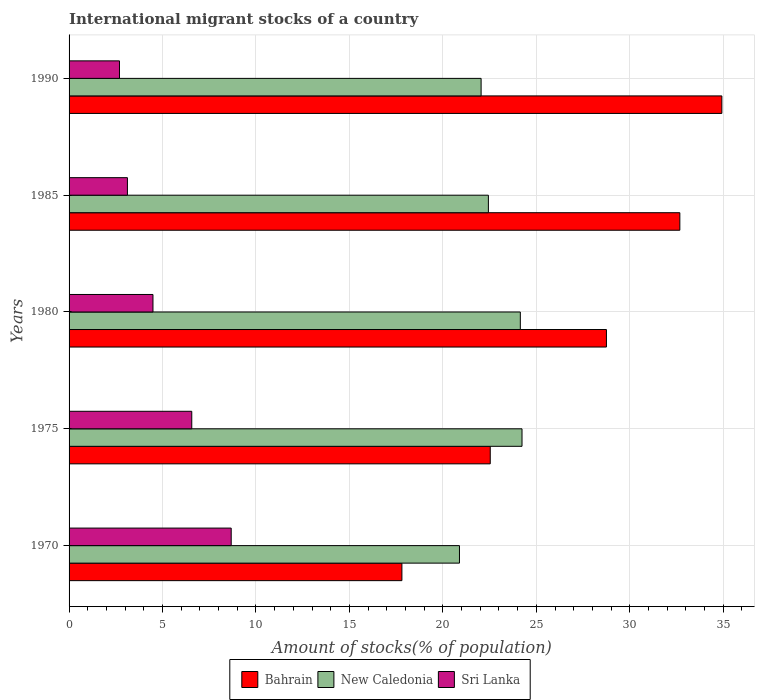How many groups of bars are there?
Your response must be concise. 5. Are the number of bars per tick equal to the number of legend labels?
Your response must be concise. Yes. How many bars are there on the 3rd tick from the top?
Your answer should be very brief. 3. What is the label of the 3rd group of bars from the top?
Make the answer very short. 1980. In how many cases, is the number of bars for a given year not equal to the number of legend labels?
Offer a terse response. 0. What is the amount of stocks in in New Caledonia in 1980?
Offer a terse response. 24.14. Across all years, what is the maximum amount of stocks in in New Caledonia?
Your answer should be very brief. 24.23. Across all years, what is the minimum amount of stocks in in Sri Lanka?
Offer a terse response. 2.7. In which year was the amount of stocks in in Bahrain maximum?
Give a very brief answer. 1990. In which year was the amount of stocks in in Sri Lanka minimum?
Provide a short and direct response. 1990. What is the total amount of stocks in in New Caledonia in the graph?
Your answer should be very brief. 113.74. What is the difference between the amount of stocks in in Sri Lanka in 1975 and that in 1985?
Your response must be concise. 3.44. What is the difference between the amount of stocks in in New Caledonia in 1970 and the amount of stocks in in Bahrain in 1985?
Offer a very short reply. -11.79. What is the average amount of stocks in in Bahrain per year?
Your answer should be compact. 27.34. In the year 1990, what is the difference between the amount of stocks in in Sri Lanka and amount of stocks in in New Caledonia?
Provide a succinct answer. -19.35. What is the ratio of the amount of stocks in in New Caledonia in 1975 to that in 1990?
Provide a succinct answer. 1.1. Is the amount of stocks in in Sri Lanka in 1975 less than that in 1990?
Offer a very short reply. No. What is the difference between the highest and the second highest amount of stocks in in Bahrain?
Your answer should be compact. 2.25. What is the difference between the highest and the lowest amount of stocks in in Sri Lanka?
Your answer should be compact. 5.98. Is the sum of the amount of stocks in in Sri Lanka in 1970 and 1990 greater than the maximum amount of stocks in in Bahrain across all years?
Offer a very short reply. No. What does the 2nd bar from the top in 1975 represents?
Your response must be concise. New Caledonia. What does the 3rd bar from the bottom in 1980 represents?
Provide a short and direct response. Sri Lanka. How many bars are there?
Your answer should be compact. 15. Does the graph contain any zero values?
Provide a succinct answer. No. Where does the legend appear in the graph?
Ensure brevity in your answer.  Bottom center. How many legend labels are there?
Provide a succinct answer. 3. How are the legend labels stacked?
Your answer should be very brief. Horizontal. What is the title of the graph?
Keep it short and to the point. International migrant stocks of a country. Does "Bermuda" appear as one of the legend labels in the graph?
Your response must be concise. No. What is the label or title of the X-axis?
Your answer should be compact. Amount of stocks(% of population). What is the Amount of stocks(% of population) of Bahrain in 1970?
Your answer should be very brief. 17.81. What is the Amount of stocks(% of population) of New Caledonia in 1970?
Make the answer very short. 20.89. What is the Amount of stocks(% of population) in Sri Lanka in 1970?
Your answer should be very brief. 8.67. What is the Amount of stocks(% of population) of Bahrain in 1975?
Provide a succinct answer. 22.53. What is the Amount of stocks(% of population) in New Caledonia in 1975?
Give a very brief answer. 24.23. What is the Amount of stocks(% of population) in Sri Lanka in 1975?
Your answer should be very brief. 6.56. What is the Amount of stocks(% of population) in Bahrain in 1980?
Ensure brevity in your answer.  28.75. What is the Amount of stocks(% of population) of New Caledonia in 1980?
Provide a succinct answer. 24.14. What is the Amount of stocks(% of population) of Sri Lanka in 1980?
Offer a very short reply. 4.49. What is the Amount of stocks(% of population) in Bahrain in 1985?
Your answer should be compact. 32.68. What is the Amount of stocks(% of population) of New Caledonia in 1985?
Provide a succinct answer. 22.43. What is the Amount of stocks(% of population) in Sri Lanka in 1985?
Ensure brevity in your answer.  3.12. What is the Amount of stocks(% of population) of Bahrain in 1990?
Your answer should be very brief. 34.92. What is the Amount of stocks(% of population) in New Caledonia in 1990?
Provide a short and direct response. 22.04. What is the Amount of stocks(% of population) of Sri Lanka in 1990?
Your response must be concise. 2.7. Across all years, what is the maximum Amount of stocks(% of population) in Bahrain?
Make the answer very short. 34.92. Across all years, what is the maximum Amount of stocks(% of population) in New Caledonia?
Your response must be concise. 24.23. Across all years, what is the maximum Amount of stocks(% of population) of Sri Lanka?
Offer a very short reply. 8.67. Across all years, what is the minimum Amount of stocks(% of population) in Bahrain?
Provide a succinct answer. 17.81. Across all years, what is the minimum Amount of stocks(% of population) of New Caledonia?
Keep it short and to the point. 20.89. Across all years, what is the minimum Amount of stocks(% of population) in Sri Lanka?
Keep it short and to the point. 2.7. What is the total Amount of stocks(% of population) of Bahrain in the graph?
Ensure brevity in your answer.  136.69. What is the total Amount of stocks(% of population) of New Caledonia in the graph?
Provide a succinct answer. 113.74. What is the total Amount of stocks(% of population) of Sri Lanka in the graph?
Keep it short and to the point. 25.54. What is the difference between the Amount of stocks(% of population) of Bahrain in 1970 and that in 1975?
Give a very brief answer. -4.73. What is the difference between the Amount of stocks(% of population) in New Caledonia in 1970 and that in 1975?
Offer a very short reply. -3.35. What is the difference between the Amount of stocks(% of population) of Sri Lanka in 1970 and that in 1975?
Offer a terse response. 2.11. What is the difference between the Amount of stocks(% of population) of Bahrain in 1970 and that in 1980?
Ensure brevity in your answer.  -10.94. What is the difference between the Amount of stocks(% of population) in New Caledonia in 1970 and that in 1980?
Your answer should be compact. -3.26. What is the difference between the Amount of stocks(% of population) of Sri Lanka in 1970 and that in 1980?
Ensure brevity in your answer.  4.19. What is the difference between the Amount of stocks(% of population) in Bahrain in 1970 and that in 1985?
Give a very brief answer. -14.87. What is the difference between the Amount of stocks(% of population) in New Caledonia in 1970 and that in 1985?
Provide a short and direct response. -1.55. What is the difference between the Amount of stocks(% of population) of Sri Lanka in 1970 and that in 1985?
Your answer should be compact. 5.55. What is the difference between the Amount of stocks(% of population) in Bahrain in 1970 and that in 1990?
Make the answer very short. -17.12. What is the difference between the Amount of stocks(% of population) of New Caledonia in 1970 and that in 1990?
Make the answer very short. -1.16. What is the difference between the Amount of stocks(% of population) in Sri Lanka in 1970 and that in 1990?
Give a very brief answer. 5.98. What is the difference between the Amount of stocks(% of population) in Bahrain in 1975 and that in 1980?
Provide a succinct answer. -6.22. What is the difference between the Amount of stocks(% of population) of New Caledonia in 1975 and that in 1980?
Provide a short and direct response. 0.09. What is the difference between the Amount of stocks(% of population) of Sri Lanka in 1975 and that in 1980?
Offer a terse response. 2.08. What is the difference between the Amount of stocks(% of population) of Bahrain in 1975 and that in 1985?
Your answer should be compact. -10.14. What is the difference between the Amount of stocks(% of population) of New Caledonia in 1975 and that in 1985?
Make the answer very short. 1.8. What is the difference between the Amount of stocks(% of population) in Sri Lanka in 1975 and that in 1985?
Offer a terse response. 3.44. What is the difference between the Amount of stocks(% of population) in Bahrain in 1975 and that in 1990?
Offer a terse response. -12.39. What is the difference between the Amount of stocks(% of population) in New Caledonia in 1975 and that in 1990?
Keep it short and to the point. 2.19. What is the difference between the Amount of stocks(% of population) of Sri Lanka in 1975 and that in 1990?
Offer a terse response. 3.87. What is the difference between the Amount of stocks(% of population) in Bahrain in 1980 and that in 1985?
Provide a succinct answer. -3.93. What is the difference between the Amount of stocks(% of population) of New Caledonia in 1980 and that in 1985?
Offer a terse response. 1.71. What is the difference between the Amount of stocks(% of population) of Sri Lanka in 1980 and that in 1985?
Provide a succinct answer. 1.37. What is the difference between the Amount of stocks(% of population) of Bahrain in 1980 and that in 1990?
Your response must be concise. -6.17. What is the difference between the Amount of stocks(% of population) in New Caledonia in 1980 and that in 1990?
Provide a short and direct response. 2.1. What is the difference between the Amount of stocks(% of population) in Sri Lanka in 1980 and that in 1990?
Make the answer very short. 1.79. What is the difference between the Amount of stocks(% of population) in Bahrain in 1985 and that in 1990?
Offer a very short reply. -2.25. What is the difference between the Amount of stocks(% of population) in New Caledonia in 1985 and that in 1990?
Give a very brief answer. 0.39. What is the difference between the Amount of stocks(% of population) of Sri Lanka in 1985 and that in 1990?
Ensure brevity in your answer.  0.43. What is the difference between the Amount of stocks(% of population) in Bahrain in 1970 and the Amount of stocks(% of population) in New Caledonia in 1975?
Provide a succinct answer. -6.43. What is the difference between the Amount of stocks(% of population) in Bahrain in 1970 and the Amount of stocks(% of population) in Sri Lanka in 1975?
Provide a short and direct response. 11.24. What is the difference between the Amount of stocks(% of population) in New Caledonia in 1970 and the Amount of stocks(% of population) in Sri Lanka in 1975?
Your response must be concise. 14.32. What is the difference between the Amount of stocks(% of population) in Bahrain in 1970 and the Amount of stocks(% of population) in New Caledonia in 1980?
Provide a succinct answer. -6.34. What is the difference between the Amount of stocks(% of population) in Bahrain in 1970 and the Amount of stocks(% of population) in Sri Lanka in 1980?
Provide a succinct answer. 13.32. What is the difference between the Amount of stocks(% of population) in New Caledonia in 1970 and the Amount of stocks(% of population) in Sri Lanka in 1980?
Your answer should be compact. 16.4. What is the difference between the Amount of stocks(% of population) of Bahrain in 1970 and the Amount of stocks(% of population) of New Caledonia in 1985?
Your response must be concise. -4.63. What is the difference between the Amount of stocks(% of population) of Bahrain in 1970 and the Amount of stocks(% of population) of Sri Lanka in 1985?
Offer a very short reply. 14.68. What is the difference between the Amount of stocks(% of population) of New Caledonia in 1970 and the Amount of stocks(% of population) of Sri Lanka in 1985?
Your answer should be very brief. 17.76. What is the difference between the Amount of stocks(% of population) of Bahrain in 1970 and the Amount of stocks(% of population) of New Caledonia in 1990?
Your answer should be very brief. -4.24. What is the difference between the Amount of stocks(% of population) of Bahrain in 1970 and the Amount of stocks(% of population) of Sri Lanka in 1990?
Make the answer very short. 15.11. What is the difference between the Amount of stocks(% of population) in New Caledonia in 1970 and the Amount of stocks(% of population) in Sri Lanka in 1990?
Keep it short and to the point. 18.19. What is the difference between the Amount of stocks(% of population) of Bahrain in 1975 and the Amount of stocks(% of population) of New Caledonia in 1980?
Offer a very short reply. -1.61. What is the difference between the Amount of stocks(% of population) of Bahrain in 1975 and the Amount of stocks(% of population) of Sri Lanka in 1980?
Give a very brief answer. 18.04. What is the difference between the Amount of stocks(% of population) in New Caledonia in 1975 and the Amount of stocks(% of population) in Sri Lanka in 1980?
Provide a short and direct response. 19.74. What is the difference between the Amount of stocks(% of population) of Bahrain in 1975 and the Amount of stocks(% of population) of New Caledonia in 1985?
Provide a succinct answer. 0.1. What is the difference between the Amount of stocks(% of population) of Bahrain in 1975 and the Amount of stocks(% of population) of Sri Lanka in 1985?
Provide a succinct answer. 19.41. What is the difference between the Amount of stocks(% of population) of New Caledonia in 1975 and the Amount of stocks(% of population) of Sri Lanka in 1985?
Keep it short and to the point. 21.11. What is the difference between the Amount of stocks(% of population) in Bahrain in 1975 and the Amount of stocks(% of population) in New Caledonia in 1990?
Provide a succinct answer. 0.49. What is the difference between the Amount of stocks(% of population) in Bahrain in 1975 and the Amount of stocks(% of population) in Sri Lanka in 1990?
Give a very brief answer. 19.84. What is the difference between the Amount of stocks(% of population) of New Caledonia in 1975 and the Amount of stocks(% of population) of Sri Lanka in 1990?
Provide a short and direct response. 21.54. What is the difference between the Amount of stocks(% of population) in Bahrain in 1980 and the Amount of stocks(% of population) in New Caledonia in 1985?
Your response must be concise. 6.32. What is the difference between the Amount of stocks(% of population) in Bahrain in 1980 and the Amount of stocks(% of population) in Sri Lanka in 1985?
Make the answer very short. 25.63. What is the difference between the Amount of stocks(% of population) of New Caledonia in 1980 and the Amount of stocks(% of population) of Sri Lanka in 1985?
Your response must be concise. 21.02. What is the difference between the Amount of stocks(% of population) of Bahrain in 1980 and the Amount of stocks(% of population) of New Caledonia in 1990?
Keep it short and to the point. 6.7. What is the difference between the Amount of stocks(% of population) of Bahrain in 1980 and the Amount of stocks(% of population) of Sri Lanka in 1990?
Ensure brevity in your answer.  26.05. What is the difference between the Amount of stocks(% of population) in New Caledonia in 1980 and the Amount of stocks(% of population) in Sri Lanka in 1990?
Your response must be concise. 21.45. What is the difference between the Amount of stocks(% of population) of Bahrain in 1985 and the Amount of stocks(% of population) of New Caledonia in 1990?
Ensure brevity in your answer.  10.63. What is the difference between the Amount of stocks(% of population) in Bahrain in 1985 and the Amount of stocks(% of population) in Sri Lanka in 1990?
Keep it short and to the point. 29.98. What is the difference between the Amount of stocks(% of population) in New Caledonia in 1985 and the Amount of stocks(% of population) in Sri Lanka in 1990?
Your answer should be compact. 19.74. What is the average Amount of stocks(% of population) of Bahrain per year?
Give a very brief answer. 27.34. What is the average Amount of stocks(% of population) in New Caledonia per year?
Provide a succinct answer. 22.75. What is the average Amount of stocks(% of population) in Sri Lanka per year?
Your response must be concise. 5.11. In the year 1970, what is the difference between the Amount of stocks(% of population) in Bahrain and Amount of stocks(% of population) in New Caledonia?
Make the answer very short. -3.08. In the year 1970, what is the difference between the Amount of stocks(% of population) of Bahrain and Amount of stocks(% of population) of Sri Lanka?
Provide a succinct answer. 9.13. In the year 1970, what is the difference between the Amount of stocks(% of population) of New Caledonia and Amount of stocks(% of population) of Sri Lanka?
Keep it short and to the point. 12.21. In the year 1975, what is the difference between the Amount of stocks(% of population) of Bahrain and Amount of stocks(% of population) of New Caledonia?
Your response must be concise. -1.7. In the year 1975, what is the difference between the Amount of stocks(% of population) in Bahrain and Amount of stocks(% of population) in Sri Lanka?
Ensure brevity in your answer.  15.97. In the year 1975, what is the difference between the Amount of stocks(% of population) of New Caledonia and Amount of stocks(% of population) of Sri Lanka?
Your answer should be very brief. 17.67. In the year 1980, what is the difference between the Amount of stocks(% of population) of Bahrain and Amount of stocks(% of population) of New Caledonia?
Offer a very short reply. 4.61. In the year 1980, what is the difference between the Amount of stocks(% of population) of Bahrain and Amount of stocks(% of population) of Sri Lanka?
Give a very brief answer. 24.26. In the year 1980, what is the difference between the Amount of stocks(% of population) of New Caledonia and Amount of stocks(% of population) of Sri Lanka?
Offer a terse response. 19.65. In the year 1985, what is the difference between the Amount of stocks(% of population) in Bahrain and Amount of stocks(% of population) in New Caledonia?
Your response must be concise. 10.24. In the year 1985, what is the difference between the Amount of stocks(% of population) of Bahrain and Amount of stocks(% of population) of Sri Lanka?
Provide a succinct answer. 29.55. In the year 1985, what is the difference between the Amount of stocks(% of population) in New Caledonia and Amount of stocks(% of population) in Sri Lanka?
Provide a short and direct response. 19.31. In the year 1990, what is the difference between the Amount of stocks(% of population) in Bahrain and Amount of stocks(% of population) in New Caledonia?
Provide a short and direct response. 12.88. In the year 1990, what is the difference between the Amount of stocks(% of population) of Bahrain and Amount of stocks(% of population) of Sri Lanka?
Your answer should be compact. 32.23. In the year 1990, what is the difference between the Amount of stocks(% of population) of New Caledonia and Amount of stocks(% of population) of Sri Lanka?
Provide a succinct answer. 19.35. What is the ratio of the Amount of stocks(% of population) of Bahrain in 1970 to that in 1975?
Keep it short and to the point. 0.79. What is the ratio of the Amount of stocks(% of population) in New Caledonia in 1970 to that in 1975?
Your answer should be very brief. 0.86. What is the ratio of the Amount of stocks(% of population) in Sri Lanka in 1970 to that in 1975?
Keep it short and to the point. 1.32. What is the ratio of the Amount of stocks(% of population) in Bahrain in 1970 to that in 1980?
Your answer should be compact. 0.62. What is the ratio of the Amount of stocks(% of population) of New Caledonia in 1970 to that in 1980?
Ensure brevity in your answer.  0.87. What is the ratio of the Amount of stocks(% of population) in Sri Lanka in 1970 to that in 1980?
Provide a short and direct response. 1.93. What is the ratio of the Amount of stocks(% of population) of Bahrain in 1970 to that in 1985?
Offer a very short reply. 0.54. What is the ratio of the Amount of stocks(% of population) in Sri Lanka in 1970 to that in 1985?
Your response must be concise. 2.78. What is the ratio of the Amount of stocks(% of population) in Bahrain in 1970 to that in 1990?
Keep it short and to the point. 0.51. What is the ratio of the Amount of stocks(% of population) in New Caledonia in 1970 to that in 1990?
Your response must be concise. 0.95. What is the ratio of the Amount of stocks(% of population) in Sri Lanka in 1970 to that in 1990?
Give a very brief answer. 3.22. What is the ratio of the Amount of stocks(% of population) of Bahrain in 1975 to that in 1980?
Offer a very short reply. 0.78. What is the ratio of the Amount of stocks(% of population) of New Caledonia in 1975 to that in 1980?
Your answer should be compact. 1. What is the ratio of the Amount of stocks(% of population) in Sri Lanka in 1975 to that in 1980?
Offer a very short reply. 1.46. What is the ratio of the Amount of stocks(% of population) of Bahrain in 1975 to that in 1985?
Provide a succinct answer. 0.69. What is the ratio of the Amount of stocks(% of population) in New Caledonia in 1975 to that in 1985?
Give a very brief answer. 1.08. What is the ratio of the Amount of stocks(% of population) of Sri Lanka in 1975 to that in 1985?
Offer a terse response. 2.1. What is the ratio of the Amount of stocks(% of population) in Bahrain in 1975 to that in 1990?
Ensure brevity in your answer.  0.65. What is the ratio of the Amount of stocks(% of population) in New Caledonia in 1975 to that in 1990?
Give a very brief answer. 1.1. What is the ratio of the Amount of stocks(% of population) of Sri Lanka in 1975 to that in 1990?
Offer a very short reply. 2.43. What is the ratio of the Amount of stocks(% of population) in Bahrain in 1980 to that in 1985?
Your answer should be very brief. 0.88. What is the ratio of the Amount of stocks(% of population) in New Caledonia in 1980 to that in 1985?
Make the answer very short. 1.08. What is the ratio of the Amount of stocks(% of population) in Sri Lanka in 1980 to that in 1985?
Make the answer very short. 1.44. What is the ratio of the Amount of stocks(% of population) of Bahrain in 1980 to that in 1990?
Ensure brevity in your answer.  0.82. What is the ratio of the Amount of stocks(% of population) in New Caledonia in 1980 to that in 1990?
Your answer should be very brief. 1.1. What is the ratio of the Amount of stocks(% of population) in Sri Lanka in 1980 to that in 1990?
Make the answer very short. 1.66. What is the ratio of the Amount of stocks(% of population) in Bahrain in 1985 to that in 1990?
Offer a very short reply. 0.94. What is the ratio of the Amount of stocks(% of population) of New Caledonia in 1985 to that in 1990?
Provide a short and direct response. 1.02. What is the ratio of the Amount of stocks(% of population) in Sri Lanka in 1985 to that in 1990?
Offer a very short reply. 1.16. What is the difference between the highest and the second highest Amount of stocks(% of population) in Bahrain?
Provide a short and direct response. 2.25. What is the difference between the highest and the second highest Amount of stocks(% of population) of New Caledonia?
Your answer should be very brief. 0.09. What is the difference between the highest and the second highest Amount of stocks(% of population) in Sri Lanka?
Offer a very short reply. 2.11. What is the difference between the highest and the lowest Amount of stocks(% of population) in Bahrain?
Provide a succinct answer. 17.12. What is the difference between the highest and the lowest Amount of stocks(% of population) of New Caledonia?
Your answer should be compact. 3.35. What is the difference between the highest and the lowest Amount of stocks(% of population) in Sri Lanka?
Make the answer very short. 5.98. 